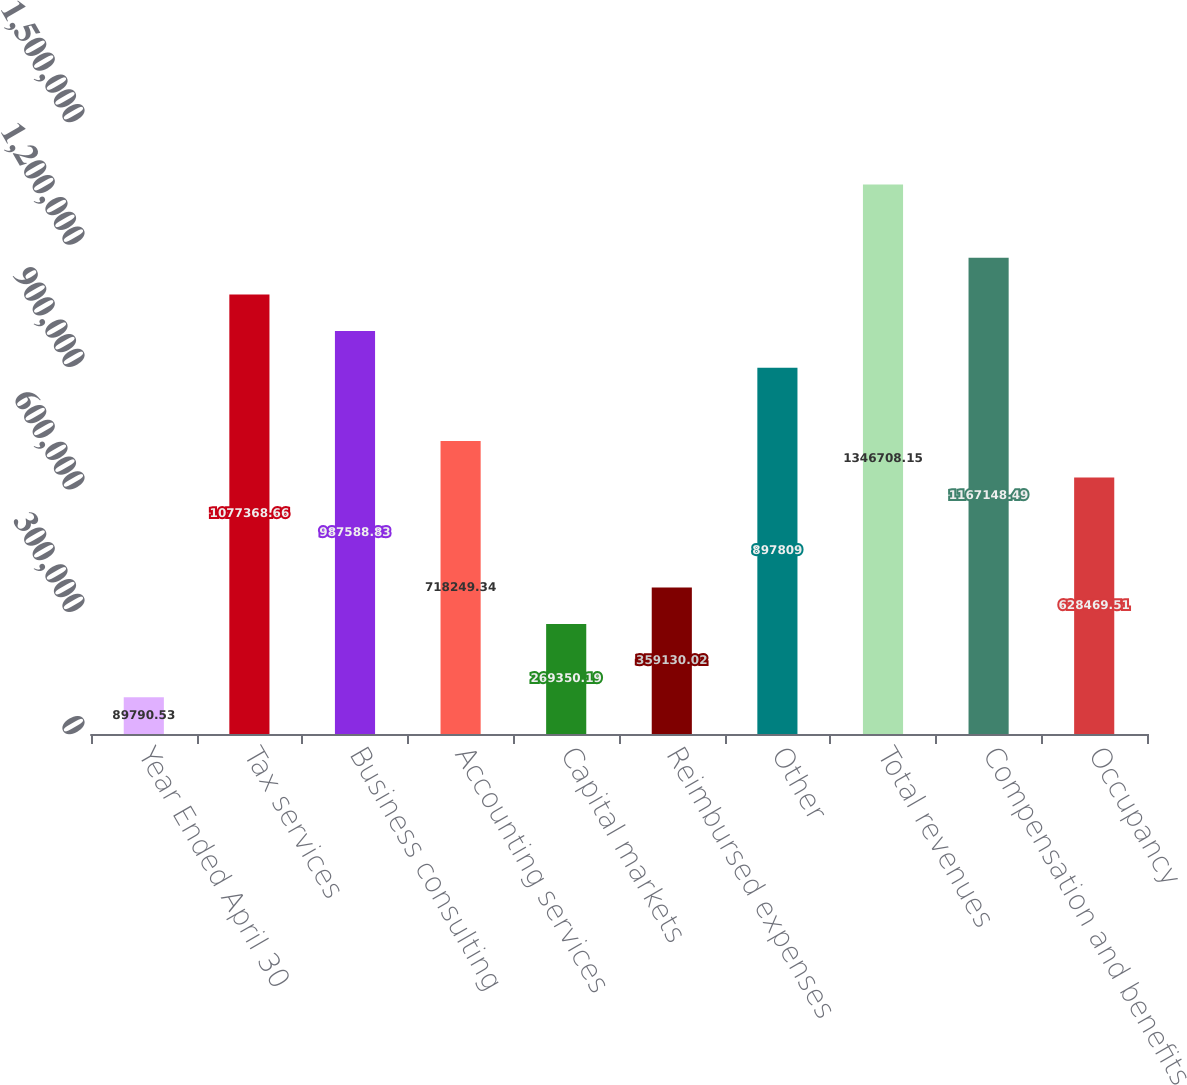<chart> <loc_0><loc_0><loc_500><loc_500><bar_chart><fcel>Year Ended April 30<fcel>Tax services<fcel>Business consulting<fcel>Accounting services<fcel>Capital markets<fcel>Reimbursed expenses<fcel>Other<fcel>Total revenues<fcel>Compensation and benefits<fcel>Occupancy<nl><fcel>89790.5<fcel>1.07737e+06<fcel>987589<fcel>718249<fcel>269350<fcel>359130<fcel>897809<fcel>1.34671e+06<fcel>1.16715e+06<fcel>628470<nl></chart> 